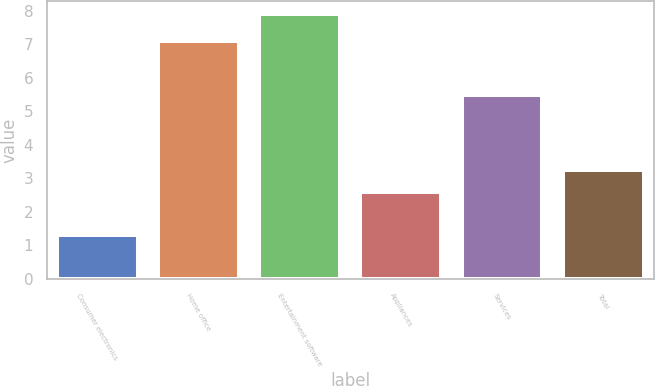<chart> <loc_0><loc_0><loc_500><loc_500><bar_chart><fcel>Consumer electronics<fcel>Home office<fcel>Entertainment software<fcel>Appliances<fcel>Services<fcel>Total<nl><fcel>1.3<fcel>7.1<fcel>7.9<fcel>2.6<fcel>5.5<fcel>3.26<nl></chart> 